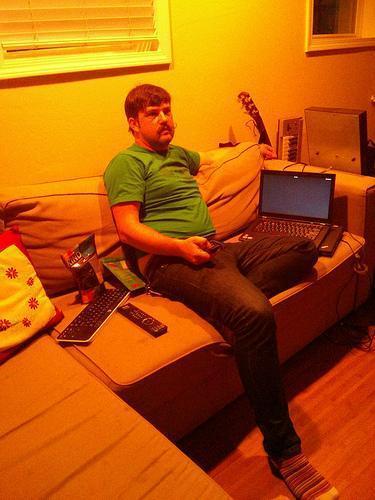How many people are there?
Give a very brief answer. 1. 